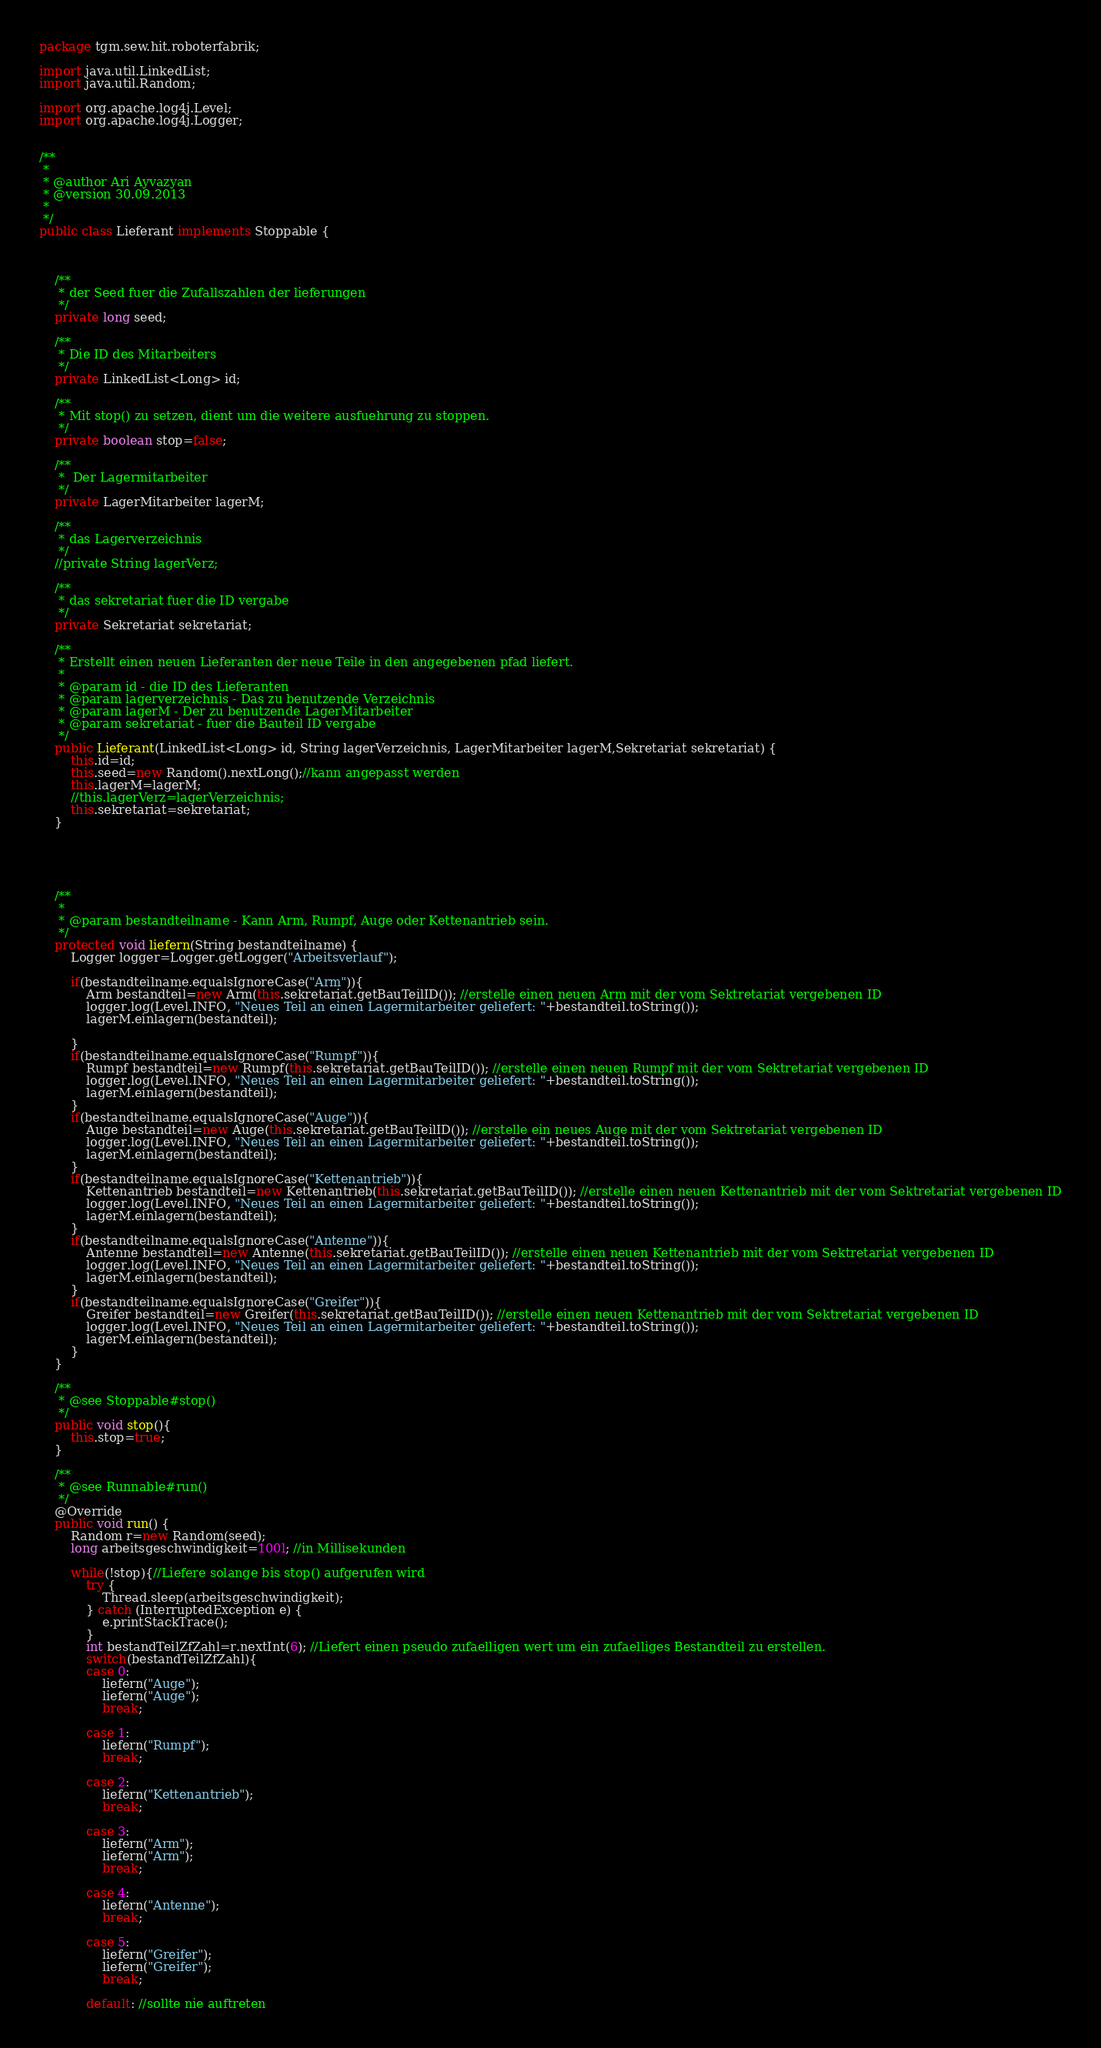<code> <loc_0><loc_0><loc_500><loc_500><_Java_>package tgm.sew.hit.roboterfabrik;

import java.util.LinkedList;
import java.util.Random;

import org.apache.log4j.Level;
import org.apache.log4j.Logger;


/**
 * 
 * @author Ari Ayvazyan
 * @version 30.09.2013
 *
 */
public class Lieferant implements Stoppable {

	
	
	/**
	 * der Seed fuer die Zufallszahlen der lieferungen
	 */
	private long seed;

	/**
	 * Die ID des Mitarbeiters
	 */
	private LinkedList<Long> id;
	
	/**
	 * Mit stop() zu setzen, dient um die weitere ausfuehrung zu stoppen.
	 */
	private boolean stop=false;
	
	/**
	 *  Der Lagermitarbeiter
	 */
	private LagerMitarbeiter lagerM;
	
	/**
	 * das Lagerverzeichnis
	 */
	//private String lagerVerz;

	/**
	 * das sekretariat fuer die ID vergabe
	 */
	private Sekretariat sekretariat;
	
	/**
	 * Erstellt einen neuen Lieferanten der neue Teile in den angegebenen pfad liefert.
	 * 
	 * @param id - die ID des Lieferanten
	 * @param lagerverzeichnis - Das zu benutzende Verzeichnis
	 * @param lagerM - Der zu benutzende LagerMitarbeiter
	 * @param sekretariat - fuer die Bauteil ID vergabe
	 */
	public Lieferant(LinkedList<Long> id, String lagerVerzeichnis, LagerMitarbeiter lagerM,Sekretariat sekretariat) {
		this.id=id;
		this.seed=new Random().nextLong();//kann angepasst werden
		this.lagerM=lagerM;
		//this.lagerVerz=lagerVerzeichnis;
		this.sekretariat=sekretariat;
	}
	
	
	
	
	
	/**
	 * 
	 * @param bestandteilname - Kann Arm, Rumpf, Auge oder Kettenantrieb sein.
	 */
	protected void liefern(String bestandteilname) {
		Logger logger=Logger.getLogger("Arbeitsverlauf");
		
		if(bestandteilname.equalsIgnoreCase("Arm")){
			Arm bestandteil=new Arm(this.sekretariat.getBauTeilID()); //erstelle einen neuen Arm mit der vom Sektretariat vergebenen ID
			logger.log(Level.INFO, "Neues Teil an einen Lagermitarbeiter geliefert: "+bestandteil.toString());
			lagerM.einlagern(bestandteil);

		}
		if(bestandteilname.equalsIgnoreCase("Rumpf")){
			Rumpf bestandteil=new Rumpf(this.sekretariat.getBauTeilID()); //erstelle einen neuen Rumpf mit der vom Sektretariat vergebenen ID
			logger.log(Level.INFO, "Neues Teil an einen Lagermitarbeiter geliefert: "+bestandteil.toString());
			lagerM.einlagern(bestandteil);
		}
		if(bestandteilname.equalsIgnoreCase("Auge")){
			Auge bestandteil=new Auge(this.sekretariat.getBauTeilID()); //erstelle ein neues Auge mit der vom Sektretariat vergebenen ID
			logger.log(Level.INFO, "Neues Teil an einen Lagermitarbeiter geliefert: "+bestandteil.toString());
			lagerM.einlagern(bestandteil);
		}
		if(bestandteilname.equalsIgnoreCase("Kettenantrieb")){
			Kettenantrieb bestandteil=new Kettenantrieb(this.sekretariat.getBauTeilID()); //erstelle einen neuen Kettenantrieb mit der vom Sektretariat vergebenen ID
			logger.log(Level.INFO, "Neues Teil an einen Lagermitarbeiter geliefert: "+bestandteil.toString());
			lagerM.einlagern(bestandteil);
		}
		if(bestandteilname.equalsIgnoreCase("Antenne")){
			Antenne bestandteil=new Antenne(this.sekretariat.getBauTeilID()); //erstelle einen neuen Kettenantrieb mit der vom Sektretariat vergebenen ID
			logger.log(Level.INFO, "Neues Teil an einen Lagermitarbeiter geliefert: "+bestandteil.toString());
			lagerM.einlagern(bestandteil);
		}
		if(bestandteilname.equalsIgnoreCase("Greifer")){
			Greifer bestandteil=new Greifer(this.sekretariat.getBauTeilID()); //erstelle einen neuen Kettenantrieb mit der vom Sektretariat vergebenen ID
			logger.log(Level.INFO, "Neues Teil an einen Lagermitarbeiter geliefert: "+bestandteil.toString());
			lagerM.einlagern(bestandteil);
		}
	}

	/**
	 * @see Stoppable#stop()
	 */
	public void stop(){ 
		this.stop=true;
	}

	/**
	 * @see Runnable#run()
	 */
	@Override
	public void run() {
		Random r=new Random(seed);
		long arbeitsgeschwindigkeit=100l; //in Millisekunden
		
		while(!stop){//Liefere solange bis stop() aufgerufen wird
			try {
				Thread.sleep(arbeitsgeschwindigkeit);
			} catch (InterruptedException e) {
				e.printStackTrace();
			}
			int bestandTeilZfZahl=r.nextInt(6); //Liefert einen pseudo zufaelligen wert um ein zufaelliges Bestandteil zu erstellen.
			switch(bestandTeilZfZahl){
			case 0:
				liefern("Auge");
				liefern("Auge");
				break;
			
			case 1:
				liefern("Rumpf");
				break;
			
			case 2:
				liefern("Kettenantrieb");
				break;
			
			case 3:
				liefern("Arm");
				liefern("Arm");
				break;
				
			case 4:
				liefern("Antenne");
				break;
				
			case 5:
				liefern("Greifer");
				liefern("Greifer");
				break;
				
			default: //sollte nie auftreten</code> 